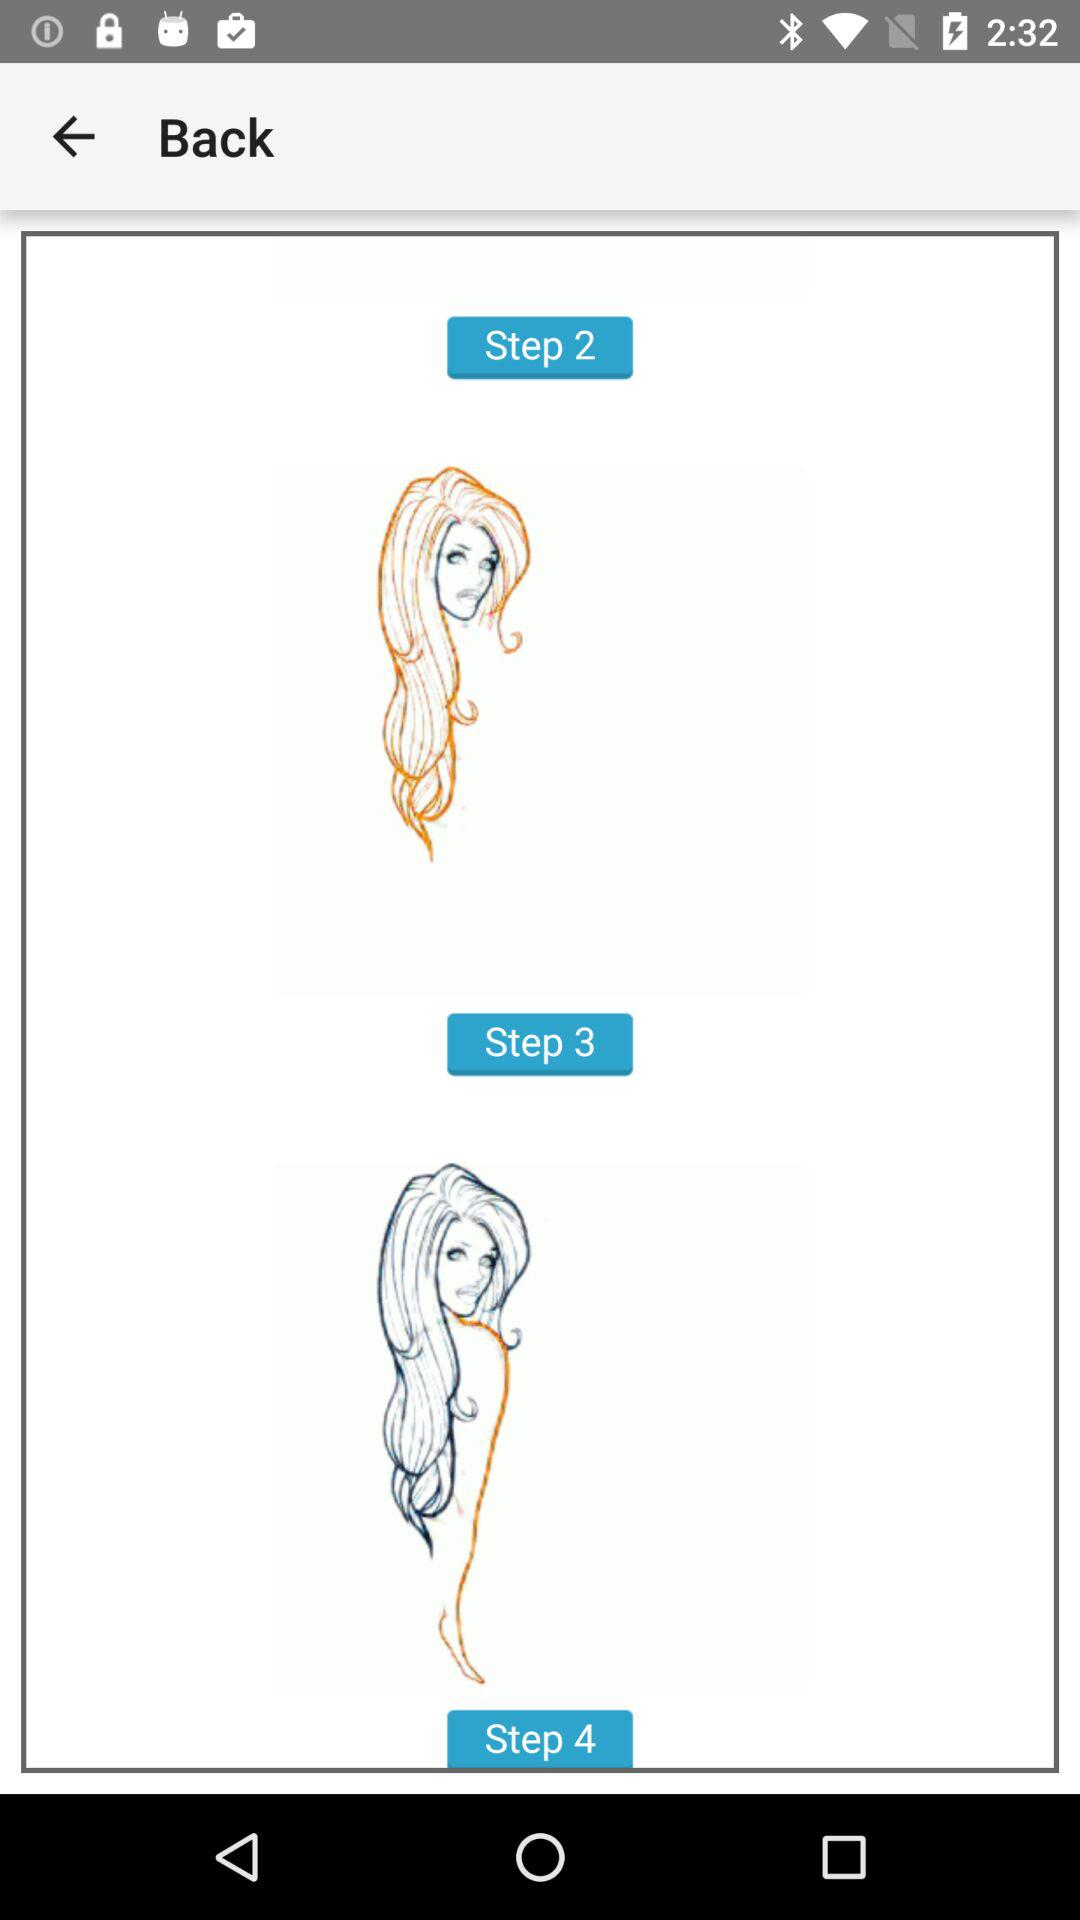How many steps are there in this tutorial?
Answer the question using a single word or phrase. 4 